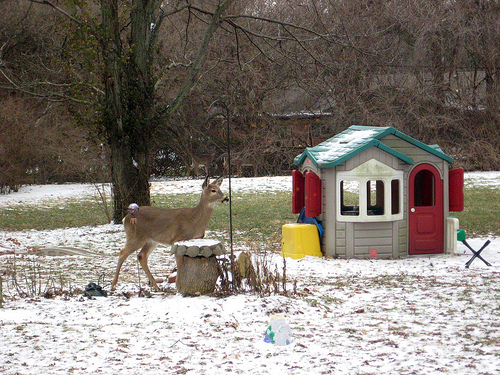<image>
Is there a deer under the tree? Yes. The deer is positioned underneath the tree, with the tree above it in the vertical space. Is the deer on the playhouse? No. The deer is not positioned on the playhouse. They may be near each other, but the deer is not supported by or resting on top of the playhouse. 